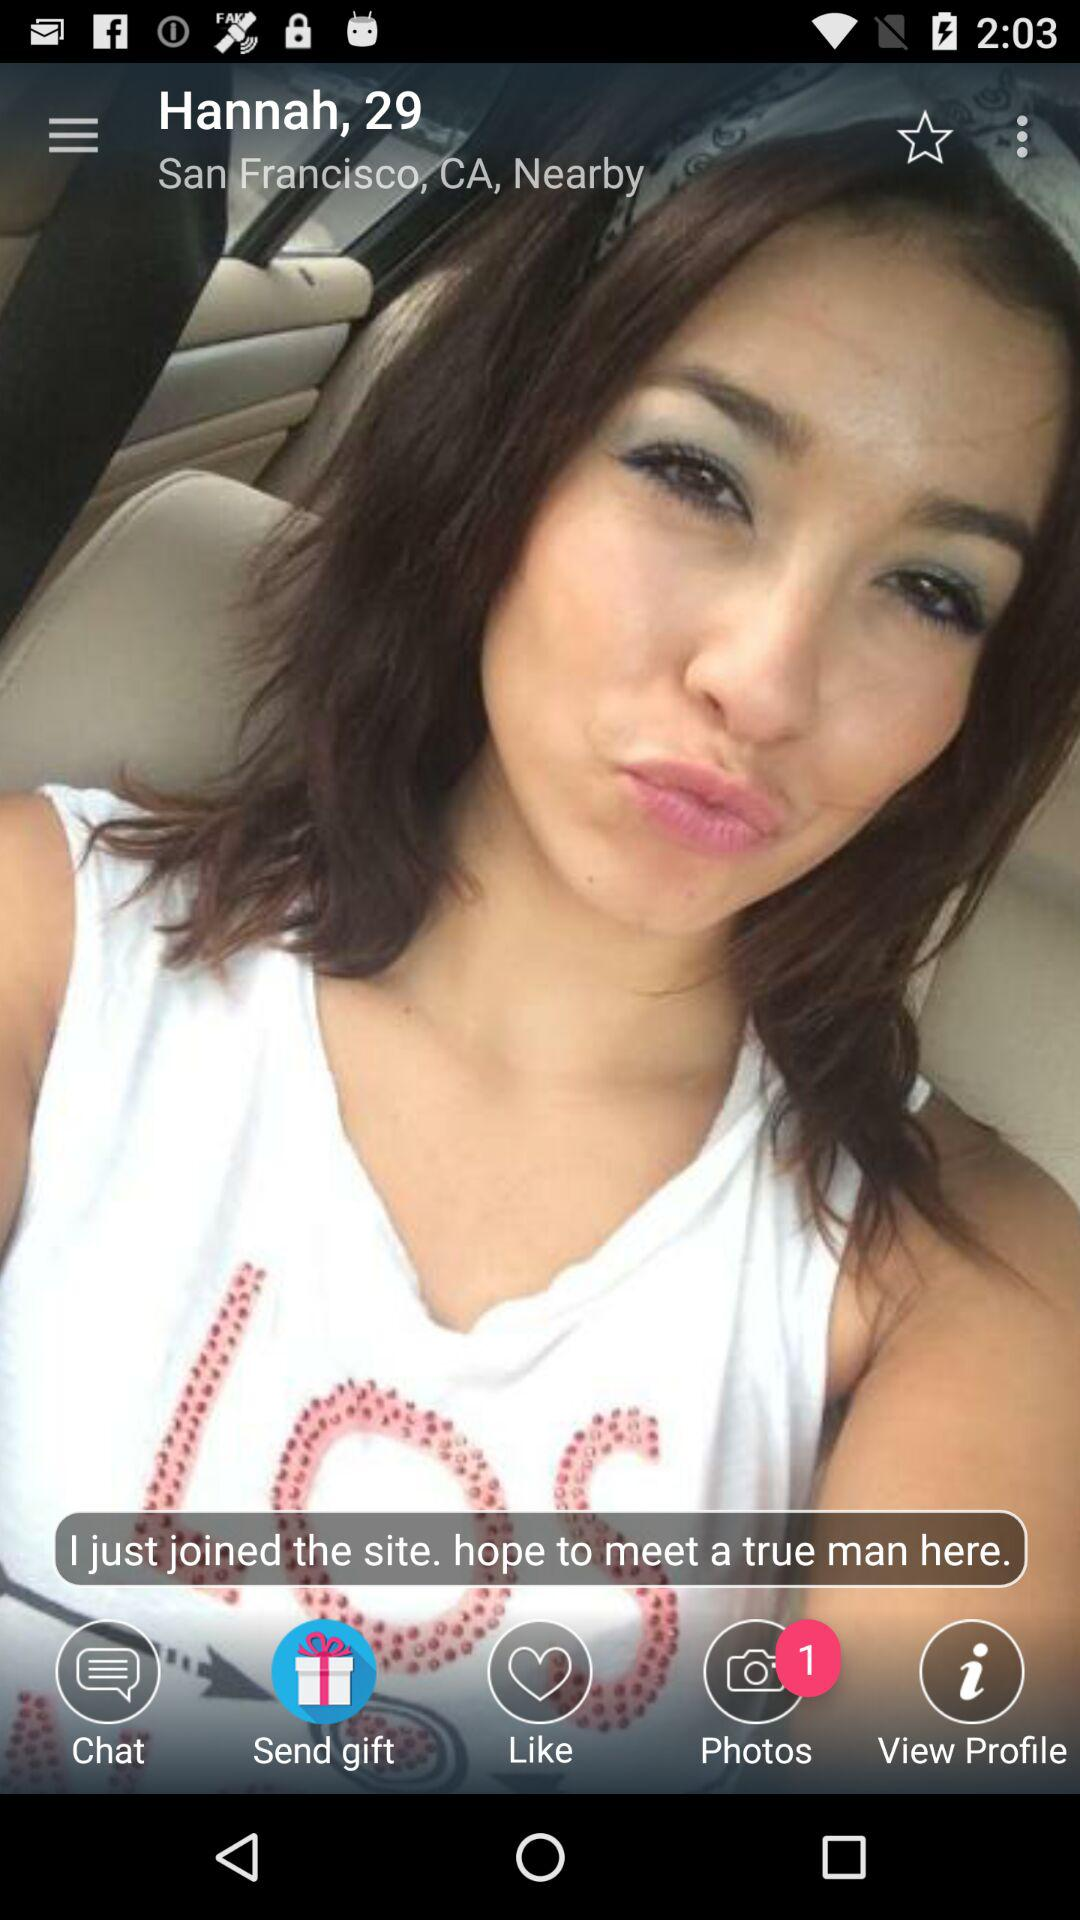What is the given age? The given age is 29. 